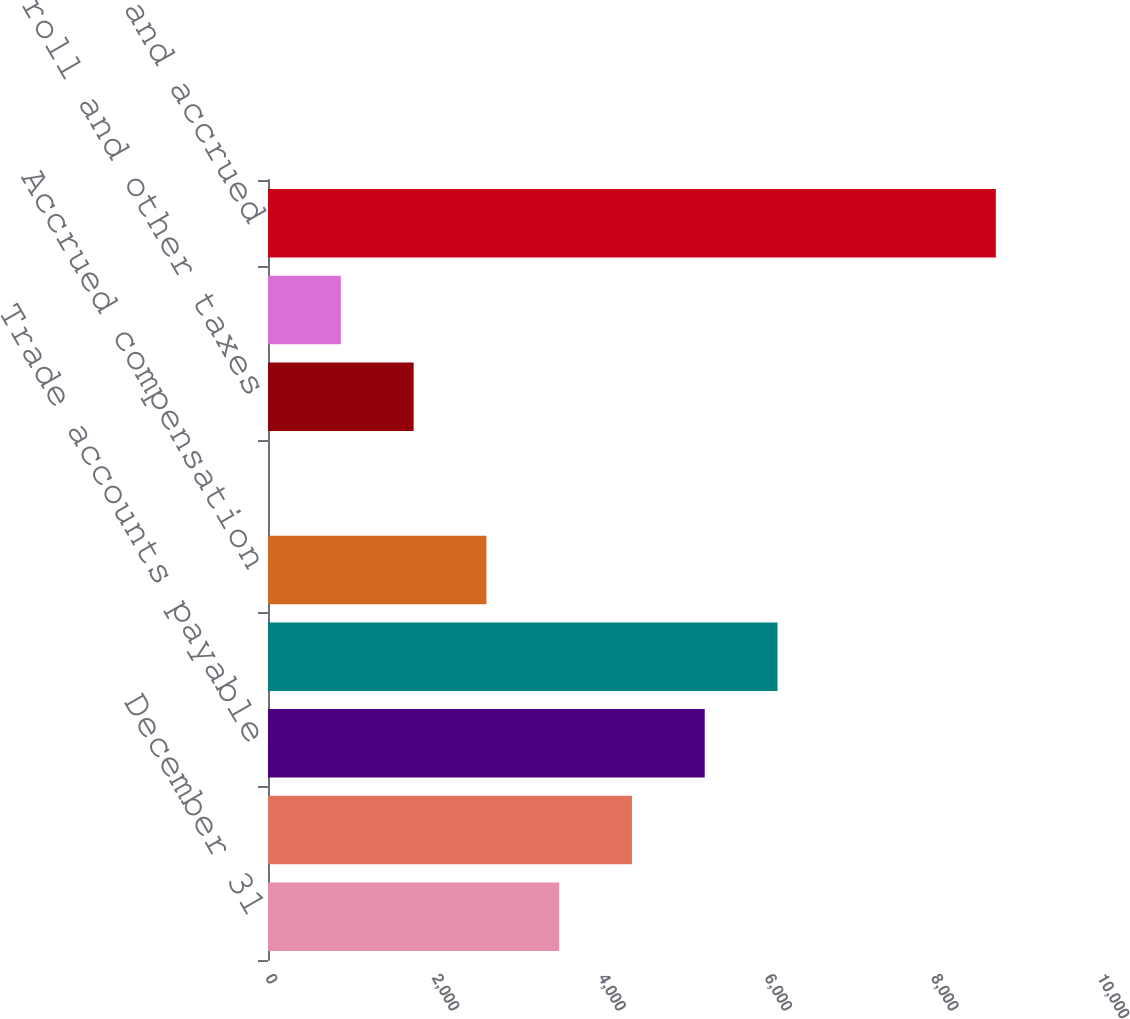Convert chart. <chart><loc_0><loc_0><loc_500><loc_500><bar_chart><fcel>December 31<fcel>Accrued marketing<fcel>Trade accounts payable<fcel>Other accrued expenses<fcel>Accrued compensation<fcel>Deferred tax liabilities<fcel>Sales payroll and other taxes<fcel>Container deposits<fcel>Accounts payable and accrued<nl><fcel>3499.8<fcel>4374.5<fcel>5249.2<fcel>6123.9<fcel>2625.1<fcel>1<fcel>1750.4<fcel>875.7<fcel>8748<nl></chart> 